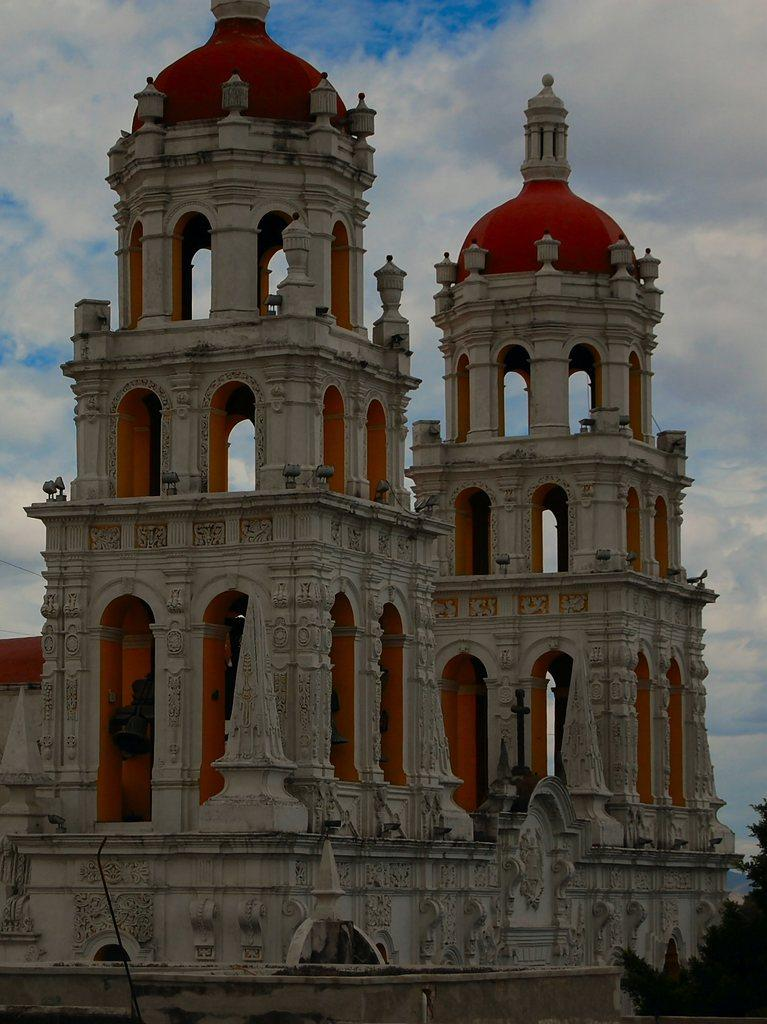What structures are the main subjects of the image? There are two temple towers in the image. What colors are the temple towers? The temple towers are white and orange in color. What architectural features can be seen on the temple towers? The temple towers have arches and domes on the top. What is visible in the background of the image? There is a sky visible in the image. What can be observed in the sky? Clouds are present in the sky. What type of bait is being used to catch fish in the image? There is no fishing or bait present in the image; it features two temple towers with arches and domes. How many bridges can be seen connecting the temple towers in the image? There are no bridges connecting the temple towers in the image; they are separate structures. 